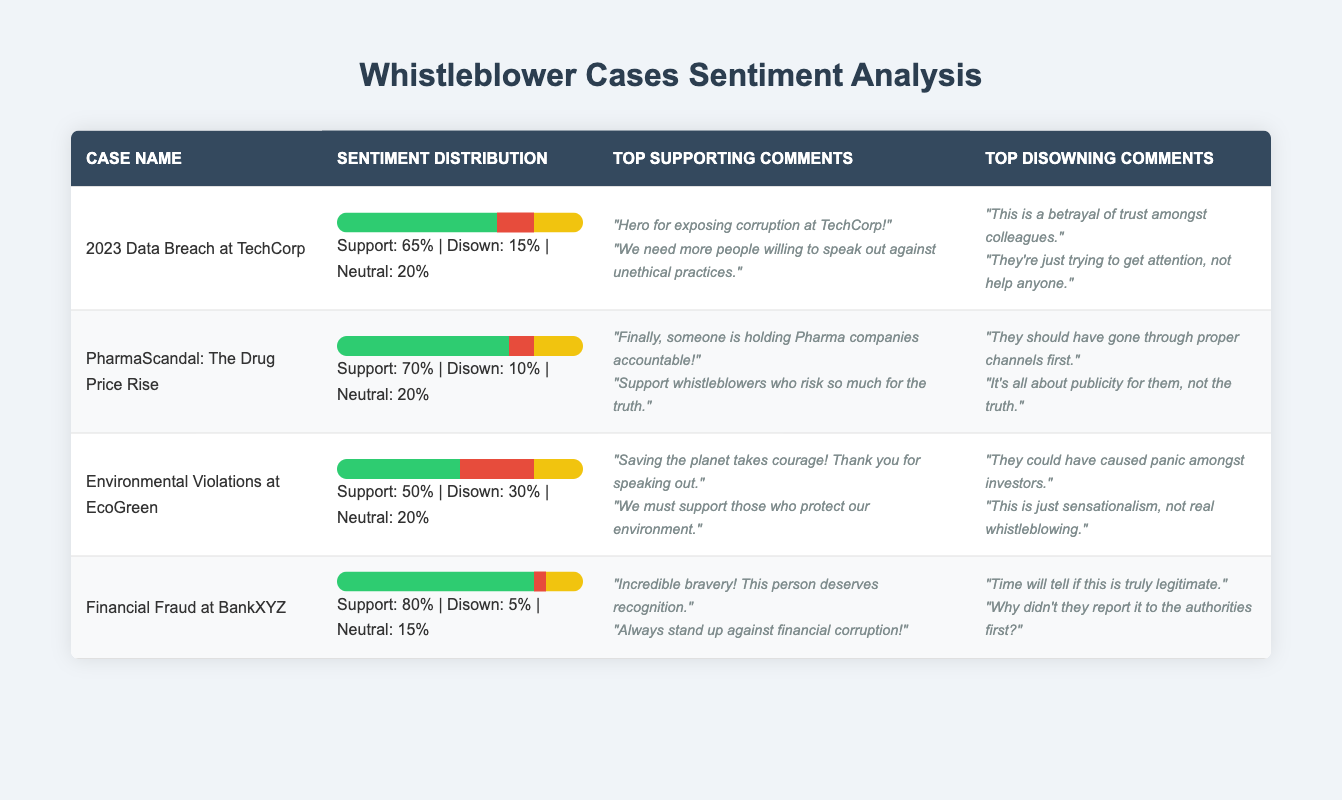What is the support percentage for the Financial Fraud at BankXYZ case? The table indicates that the support percentage for the case "Financial Fraud at BankXYZ" is presented under the "Sentiment Distribution" column. According to the data, it states "Support: 80%"
Answer: 80% Which case has the highest disown percentage? By reviewing the "disown percentage" values in the table for each case, we find that "Environmental Violations at EcoGreen" has a disown percentage of 30%. This is higher than all other cases listed
Answer: Environmental Violations at EcoGreen What is the average support percentage across all cases? To calculate the average support percentage, we’ll sum the support percentages (65 + 70 + 50 + 80) = 265, and then divide by the number of cases (4): 265 / 4 = 66.25
Answer: 66.25 True or false: The PharmaScandal case has a higher support percentage than the 2023 Data Breach case. The data shows a support percentage of 70% for PharmaScandal and 65% for the 2023 Data Breach. Since 70% is greater than 65%, the statement is true
Answer: True What is the difference in support percentage between the case with the highest support and the one with the lowest support? The case with the highest support percentage is "Financial Fraud at BankXYZ" at 80%, and the case with the lowest support is "Environmental Violations at EcoGreen" at 50%. The difference is 80% - 50% = 30%
Answer: 30% What percentage of comments are neutral for the Environmental Violations case? In the table under the "Sentiment Distribution" for the Environmental Violations case, it shows a neutral percentage of 20%. Thus, the percentage of comments that are neutral is 20%
Answer: 20% Which case had the least amount of public support based on the top supporting comments? By examining the top supporting comments and their sentiment, we find that the "Environmental Violations at EcoGreen" case features strong support but with a support percentage of only 50%, which is the lowest compared to others. While the comments were positive, the support percentage itself indicates the lowest overall public sentiment
Answer: Environmental Violations at EcoGreen How many cases have a support percentage above 60%? Analyzing the support percentages, we find the following cases: "2023 Data Breach at TechCorp" (65%), "PharmaScandal" (70%), and "Financial Fraud at BankXYZ" (80%). This totals to three cases with support percentages above 60%.
Answer: 3 